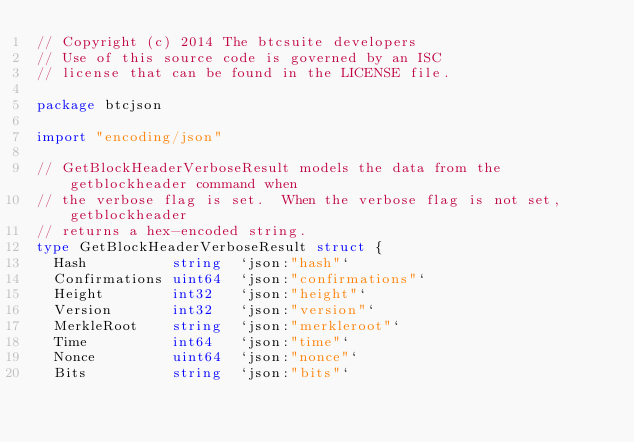Convert code to text. <code><loc_0><loc_0><loc_500><loc_500><_Go_>// Copyright (c) 2014 The btcsuite developers
// Use of this source code is governed by an ISC
// license that can be found in the LICENSE file.

package btcjson

import "encoding/json"

// GetBlockHeaderVerboseResult models the data from the getblockheader command when
// the verbose flag is set.  When the verbose flag is not set, getblockheader
// returns a hex-encoded string.
type GetBlockHeaderVerboseResult struct {
	Hash          string  `json:"hash"`
	Confirmations uint64  `json:"confirmations"`
	Height        int32   `json:"height"`
	Version       int32   `json:"version"`
	MerkleRoot    string  `json:"merkleroot"`
	Time          int64   `json:"time"`
	Nonce         uint64  `json:"nonce"`
	Bits          string  `json:"bits"`</code> 